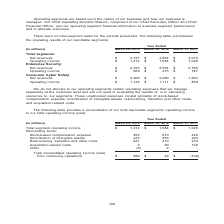According to Nortonlifelock's financial document, What do unallocated expenses consist primarily of? stock-based compensation expense; amortization of intangible assets; restructuring, transition and other costs; and acquisition-related costs. The document states: ". These unallocated expenses consist primarily of stock-based compensation expense; amortization of intangible assets; restructuring, transition and o..." Also, What does this table show? reconciliation of our total reportable segments’ operating income to our total operating income (loss). The document states: "The following table provides a reconciliation of our total reportable segments’ operating income to our total operating income (loss):..." Also, What is the Total segment operating income for year ended  March 29, 2019? According to the financial document, $1,414 (in millions). The relevant text states: "venues $ 4,731 $ 4,834 $ 4,019 Operating income $ 1,414 $ 1,584 $ 1,026 Enterprise Security: Net revenues $ 2,323 $ 2,554 $ 2,355 Operating income $ 269 $..." Also, can you calculate: What is the average  Total consolidated operating income (loss) from continuing operations for the fiscal years 2019, 2018 and 2017? To answer this question, I need to perform calculations using the financial data. The calculation is: (380+49+(-100))/3, which equals 109.67 (in millions). This is based on the information: "income (loss) from continuing operations $ 380 $ 49 $ (100) e (loss) from continuing operations $ 380 $ 49 $ (100) rating income (loss) from continuing operations $ 380 $ 49 $ (100) rating income (los..." The key data points involved are: 100, 3, 380. Also, can you calculate: What is  Amortization of intangible assets expressed as a percentage of  Total segment operating income for fiscal year 2019? Based on the calculation: 443/1,414, the result is 31.33 (percentage). This is based on the information: "venues $ 4,731 $ 4,834 $ 4,019 Operating income $ 1,414 $ 1,584 $ 1,026 Enterprise Security: Net revenues $ 2,323 $ 2,554 $ 2,355 Operating income $ 269 $ nse 352 610 440 Amortization of intangible as..." The key data points involved are: 1,414, 443. Also, can you calculate: What is the  Total consolidated operating income (loss) from continuing operations expressed as a percentage of  Total segment operating income for fiscal year 2019? Based on the calculation: 380/1,414, the result is 26.87 (percentage). This is based on the information: "venues $ 4,731 $ 4,834 $ 4,019 Operating income $ 1,414 $ 1,584 $ 1,026 Enterprise Security: Net revenues $ 2,323 $ 2,554 $ 2,355 Operating income $ 269 $ rating income (loss) from continuing operatio..." The key data points involved are: 1,414, 380. 